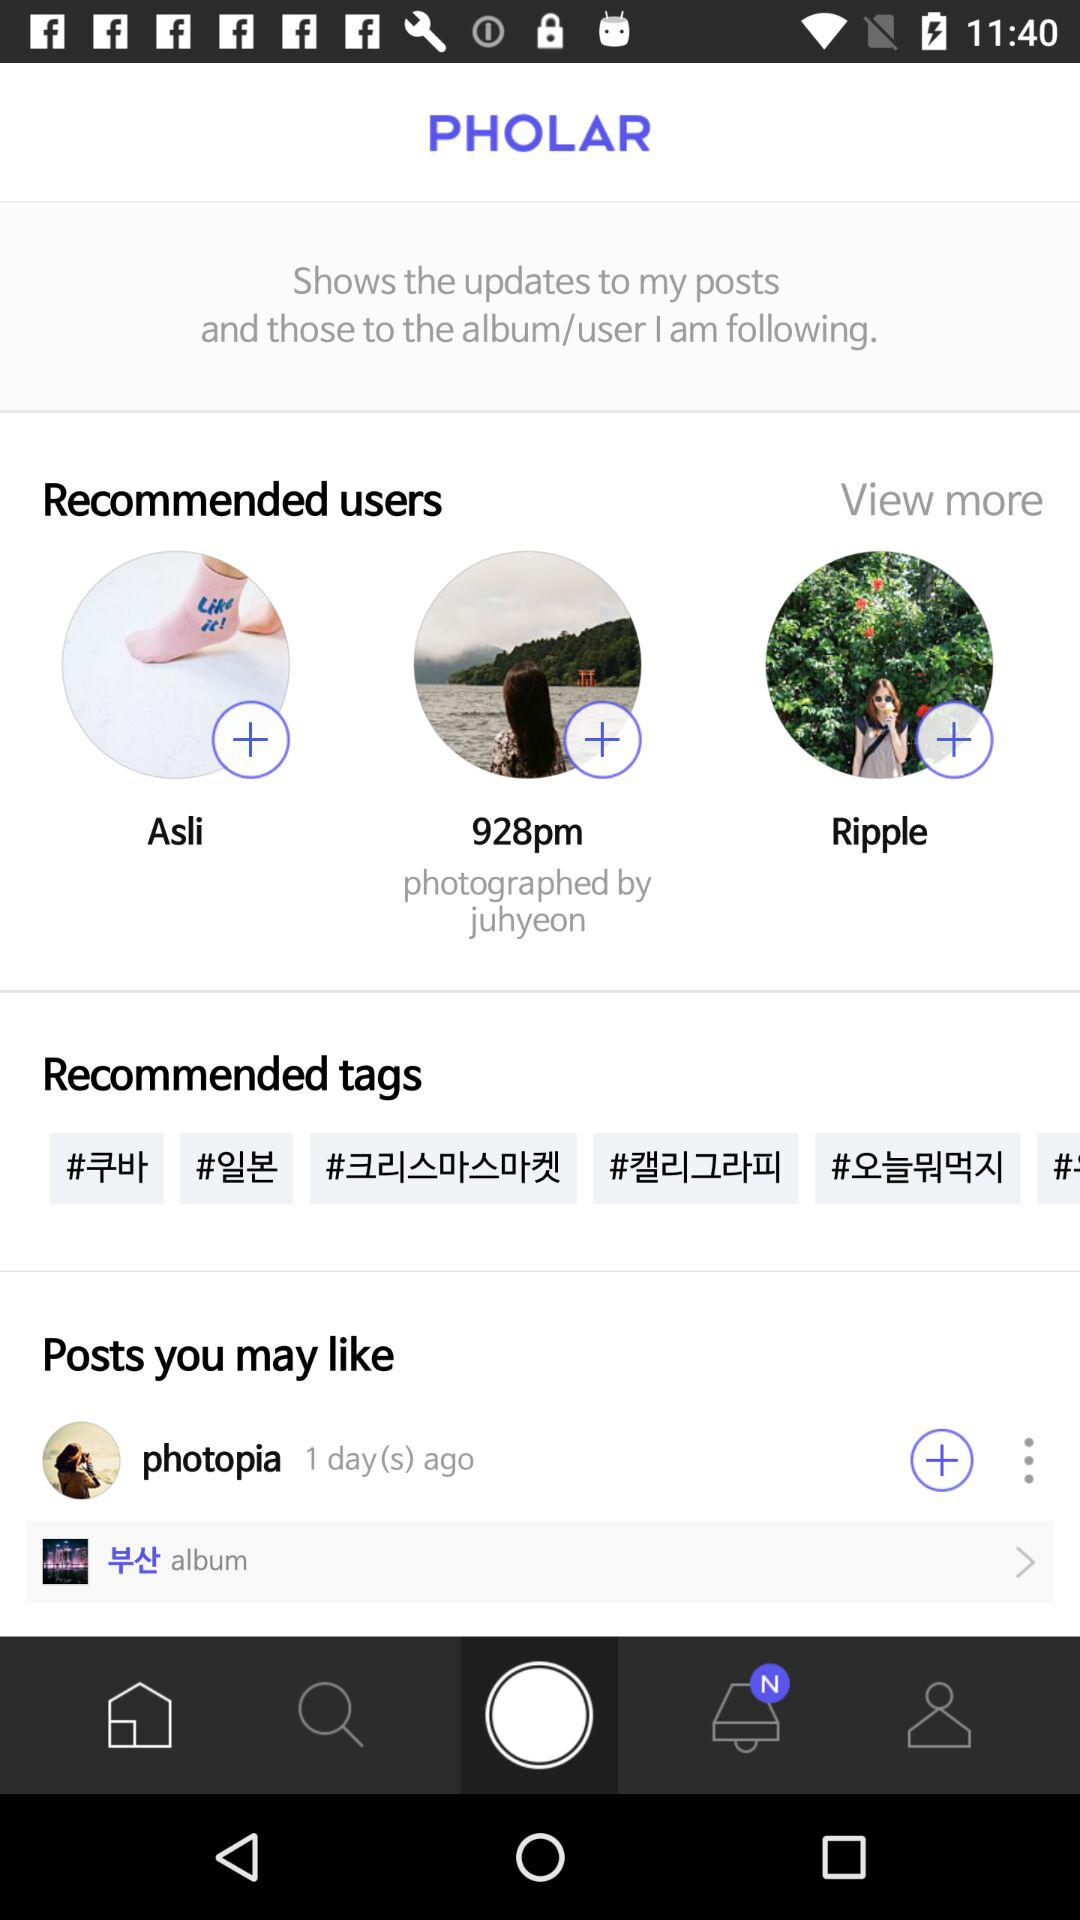How many days ago was the post posted by "photopia"? The post was posted 1 day ago. 